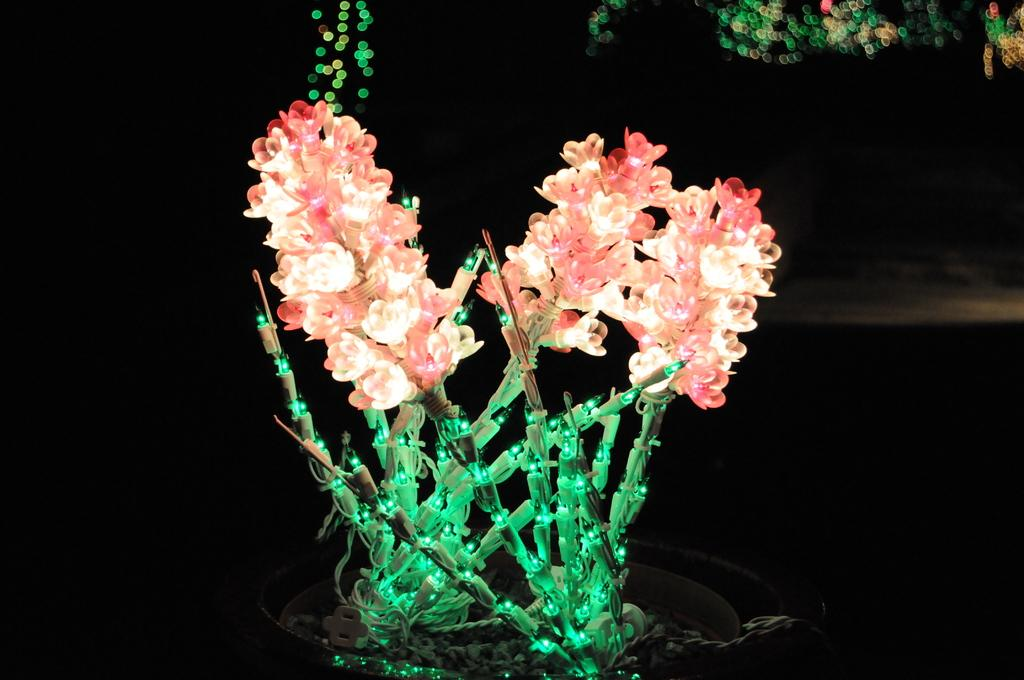What type of lighting is present in the image? There are decorative lights in the image. What else can be seen in the image besides the lights? There are wires visible in the image. What is the color of the background in the image? The background of the image is dark. Can you tell me how many wrists are visible in the image? There are no wrists present in the image; it features decorative lights and wires. What type of nose can be seen on the decorative lights in the image? There are no noses present on the decorative lights in the image; they are simply lights and wires. 